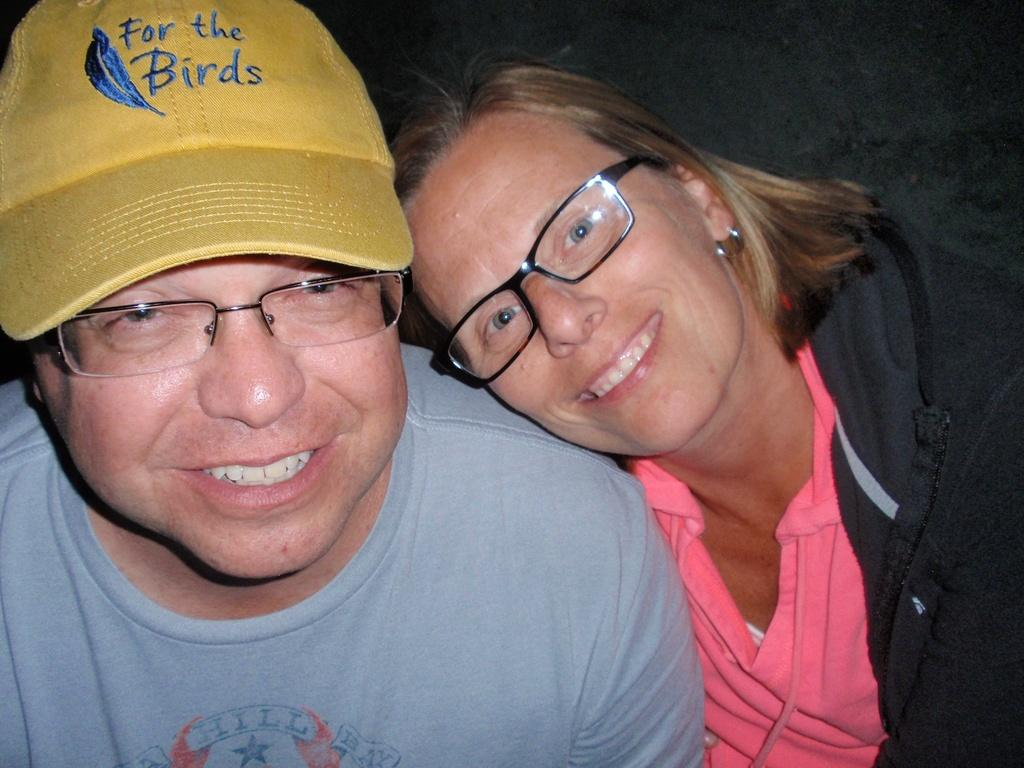How many people are in the image? There are two people in the image. What is the facial expression of the people in the image? Both people are smiling. What accessory do both people have in common? Both people are wearing spectacles. Can you describe the man's attire in the image? The man is wearing a yellow cap. What is the woman wearing in the image? The woman is wearing a jacket. What type of cakes are being served from the truck in the image? There is no truck or cakes present in the image; it features two people wearing spectacles and smiling. Can you recite the verse that is written on the woman's jacket in the image? There is no verse written on the woman's jacket in the image; she is simply wearing a jacket. 